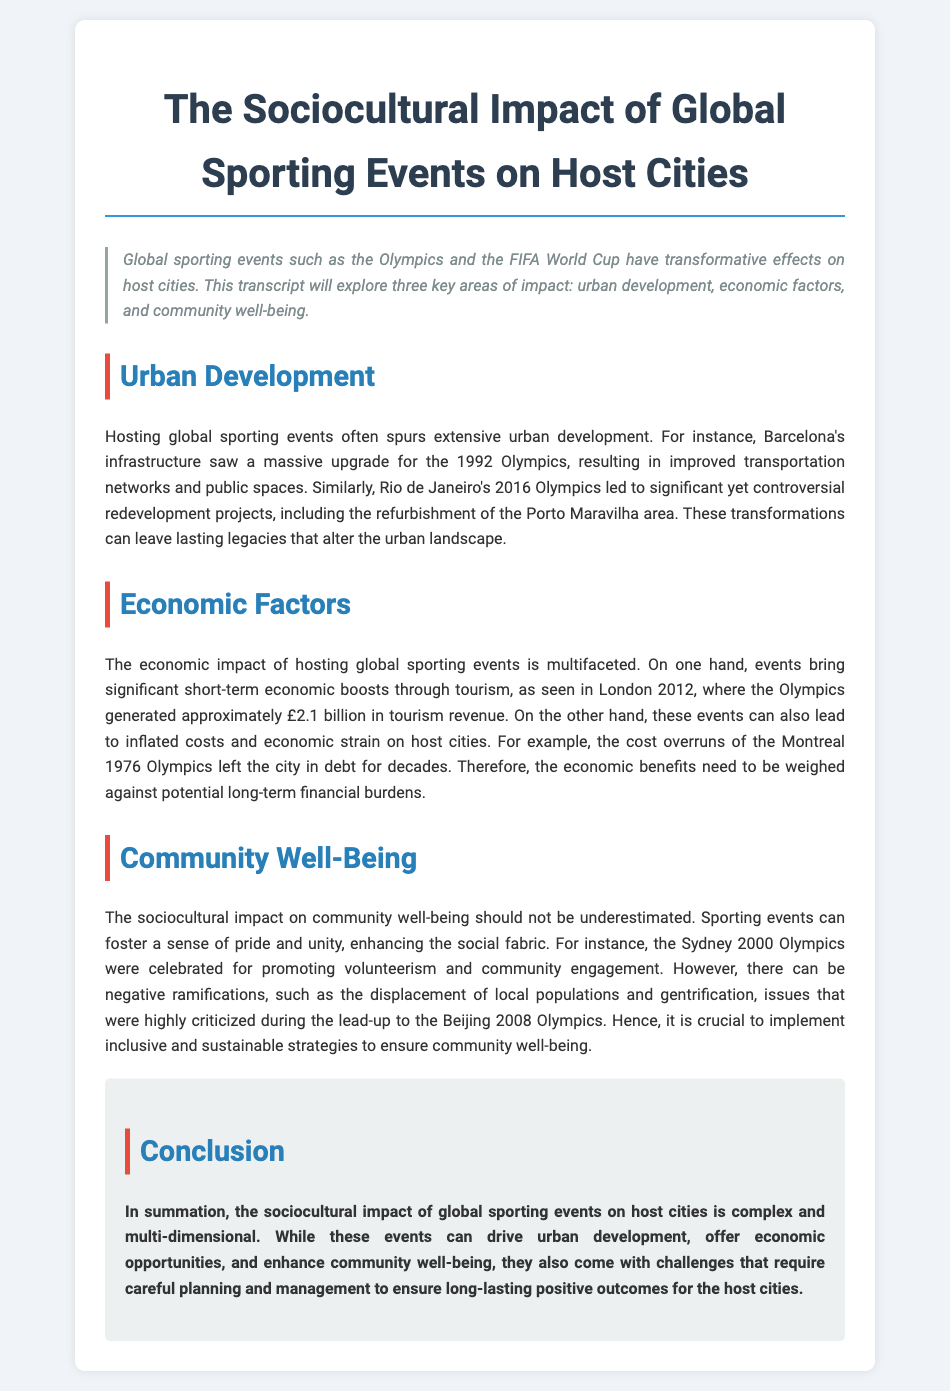What year did the Barcelona Olympics take place? The document states that Barcelona's infrastructure saw improvements for the 1992 Olympics.
Answer: 1992 What economic boost did the London 2012 Olympics generate in tourism revenue? The document mentions that the London 2012 Olympics generated approximately £2.1 billion in tourism revenue.
Answer: £2.1 billion What was a significant urban development project from the Rio de Janeiro 2016 Olympics? The document references the refurbishment of the Porto Maravilha area as a redevelopment project from the Rio de Janeiro 2016 Olympics.
Answer: Porto Maravilha Which Olympics were noted for promoting volunteerism and community engagement? The document highlights that the Sydney 2000 Olympics were celebrated for promoting volunteerism and community engagement.
Answer: Sydney 2000 What negative issue was criticized during the Beijing 2008 Olympics? The document states that displacement of local populations and gentrification were criticized during the lead-up to the Beijing 2008 Olympics.
Answer: Displacement of local populations What complex impact should be carefully managed according to the conclusion? The conclusion emphasizes that the sociocultural impact of global sporting events is complex and requires careful planning and management.
Answer: Sociocultural impact 